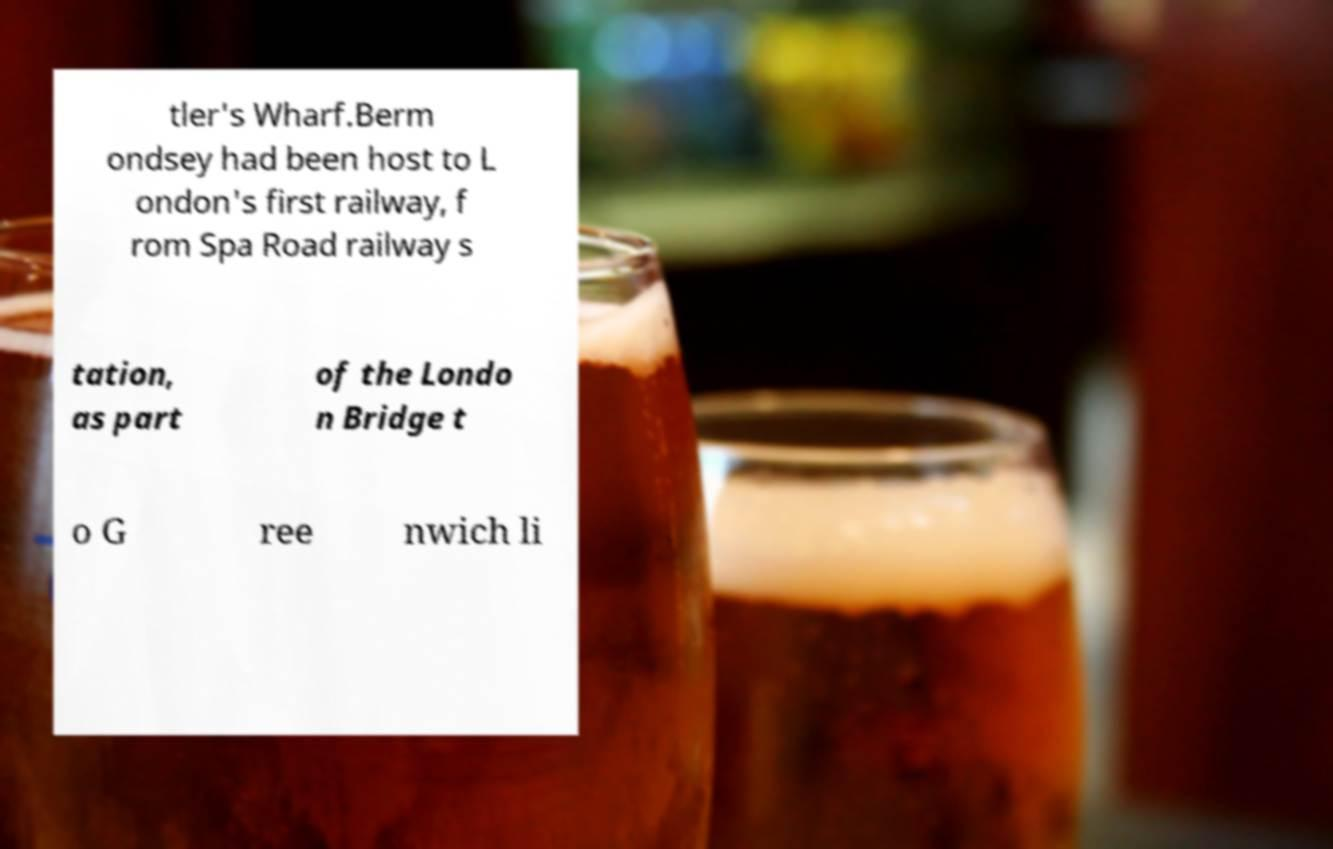I need the written content from this picture converted into text. Can you do that? tler's Wharf.Berm ondsey had been host to L ondon's first railway, f rom Spa Road railway s tation, as part of the Londo n Bridge t o G ree nwich li 